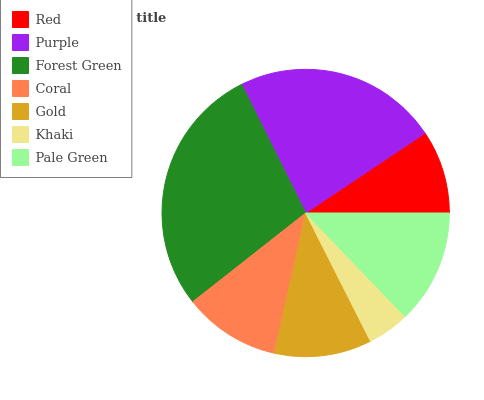Is Khaki the minimum?
Answer yes or no. Yes. Is Forest Green the maximum?
Answer yes or no. Yes. Is Purple the minimum?
Answer yes or no. No. Is Purple the maximum?
Answer yes or no. No. Is Purple greater than Red?
Answer yes or no. Yes. Is Red less than Purple?
Answer yes or no. Yes. Is Red greater than Purple?
Answer yes or no. No. Is Purple less than Red?
Answer yes or no. No. Is Gold the high median?
Answer yes or no. Yes. Is Gold the low median?
Answer yes or no. Yes. Is Pale Green the high median?
Answer yes or no. No. Is Red the low median?
Answer yes or no. No. 